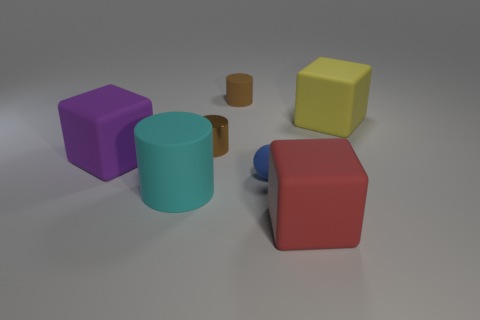How many objects are either large matte objects that are behind the cyan matte cylinder or cubes that are left of the large red rubber block?
Your response must be concise. 2. Do the rubber ball and the purple object have the same size?
Ensure brevity in your answer.  No. Is there anything else that has the same size as the purple cube?
Your response must be concise. Yes. Do the big rubber object behind the tiny metallic cylinder and the brown thing in front of the yellow thing have the same shape?
Your answer should be very brief. No. What size is the ball?
Make the answer very short. Small. What is the big cyan object that is in front of the rubber block on the left side of the rubber block that is in front of the blue sphere made of?
Keep it short and to the point. Rubber. How many other objects are there of the same color as the matte ball?
Provide a succinct answer. 0. How many green things are either matte spheres or large things?
Offer a very short reply. 0. What is the large block right of the red cube made of?
Offer a very short reply. Rubber. Is the large block that is behind the purple rubber object made of the same material as the blue thing?
Keep it short and to the point. Yes. 